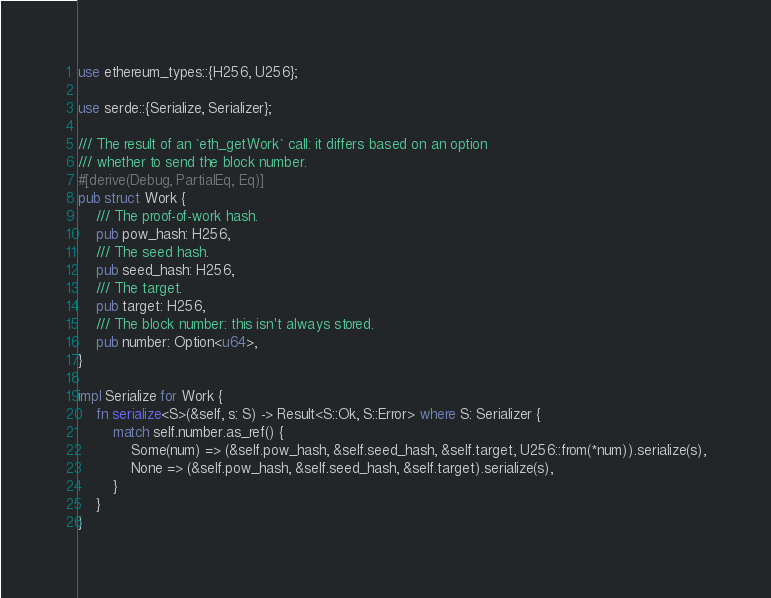<code> <loc_0><loc_0><loc_500><loc_500><_Rust_>
use ethereum_types::{H256, U256};

use serde::{Serialize, Serializer};

/// The result of an `eth_getWork` call: it differs based on an option
/// whether to send the block number.
#[derive(Debug, PartialEq, Eq)]
pub struct Work {
	/// The proof-of-work hash.
	pub pow_hash: H256,
	/// The seed hash.
	pub seed_hash: H256,
	/// The target.
	pub target: H256,
	/// The block number: this isn't always stored.
	pub number: Option<u64>,
}

impl Serialize for Work {
	fn serialize<S>(&self, s: S) -> Result<S::Ok, S::Error> where S: Serializer {
		match self.number.as_ref() {
			Some(num) => (&self.pow_hash, &self.seed_hash, &self.target, U256::from(*num)).serialize(s),
			None => (&self.pow_hash, &self.seed_hash, &self.target).serialize(s),
		}
	}
}
</code> 